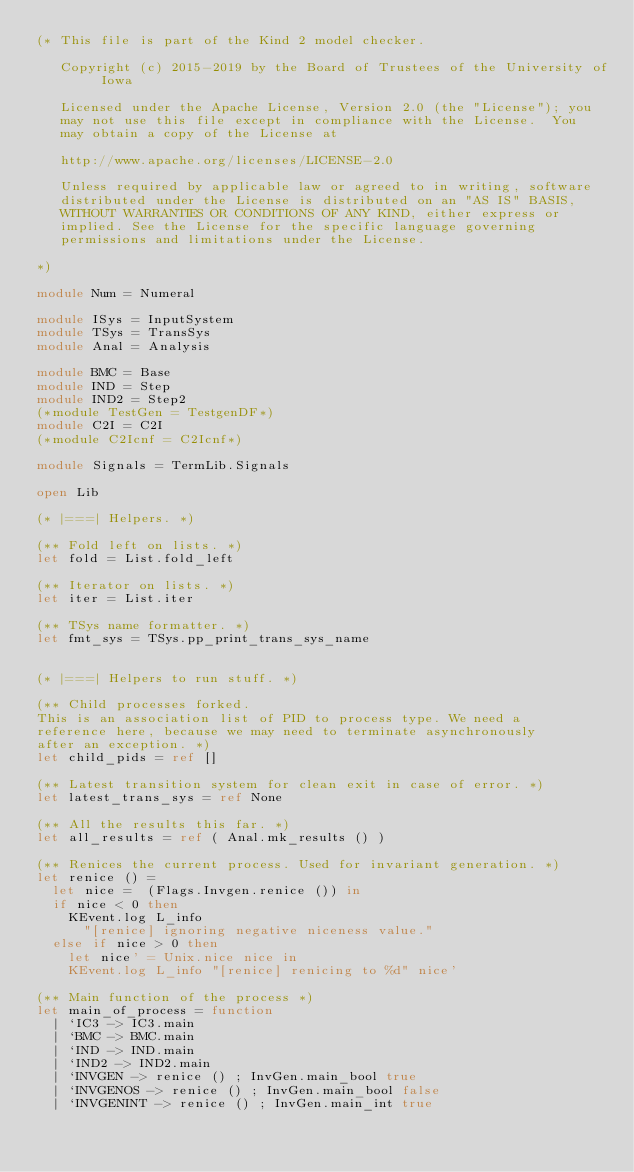<code> <loc_0><loc_0><loc_500><loc_500><_OCaml_>(* This file is part of the Kind 2 model checker.

   Copyright (c) 2015-2019 by the Board of Trustees of the University of Iowa

   Licensed under the Apache License, Version 2.0 (the "License"); you
   may not use this file except in compliance with the License.  You
   may obtain a copy of the License at

   http://www.apache.org/licenses/LICENSE-2.0 

   Unless required by applicable law or agreed to in writing, software
   distributed under the License is distributed on an "AS IS" BASIS,
   WITHOUT WARRANTIES OR CONDITIONS OF ANY KIND, either express or
   implied. See the License for the specific language governing
   permissions and limitations under the License. 

*)

module Num = Numeral

module ISys = InputSystem
module TSys = TransSys
module Anal = Analysis

module BMC = Base
module IND = Step
module IND2 = Step2
(*module TestGen = TestgenDF*)
module C2I = C2I
(*module C2Icnf = C2Icnf*)

module Signals = TermLib.Signals

open Lib

(* |===| Helpers. *)

(** Fold left on lists. *)
let fold = List.fold_left

(** Iterator on lists. *)
let iter = List.iter

(** TSys name formatter. *)
let fmt_sys = TSys.pp_print_trans_sys_name


(* |===| Helpers to run stuff. *)

(** Child processes forked.
This is an association list of PID to process type. We need a
reference here, because we may need to terminate asynchronously
after an exception. *)
let child_pids = ref []

(** Latest transition system for clean exit in case of error. *)
let latest_trans_sys = ref None

(** All the results this far. *)
let all_results = ref ( Anal.mk_results () )

(** Renices the current process. Used for invariant generation. *)
let renice () =
  let nice =  (Flags.Invgen.renice ()) in
  if nice < 0 then
    KEvent.log L_info
      "[renice] ignoring negative niceness value."
  else if nice > 0 then
    let nice' = Unix.nice nice in
    KEvent.log L_info "[renice] renicing to %d" nice'

(** Main function of the process *)
let main_of_process = function
  | `IC3 -> IC3.main
  | `BMC -> BMC.main
  | `IND -> IND.main
  | `IND2 -> IND2.main
  | `INVGEN -> renice () ; InvGen.main_bool true
  | `INVGENOS -> renice () ; InvGen.main_bool false
  | `INVGENINT -> renice () ; InvGen.main_int true</code> 